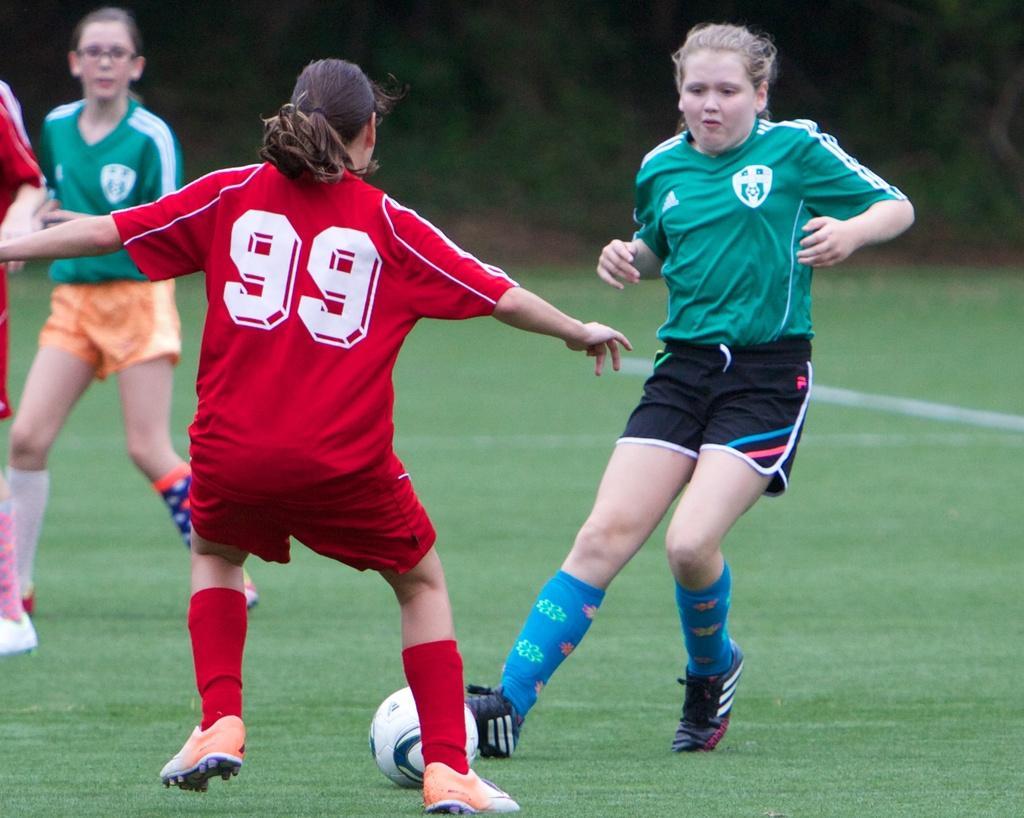In one or two sentences, can you explain what this image depicts? In the middle there is a woman she is playing football ,she wear a red t shirt her hair is short. On the right there is a woman she is staring at football ,she wear green t shirt ,trouser , shocks and shoes. On the left there is a woman she wear a green t shirt ,trouser , socks and shoes. 